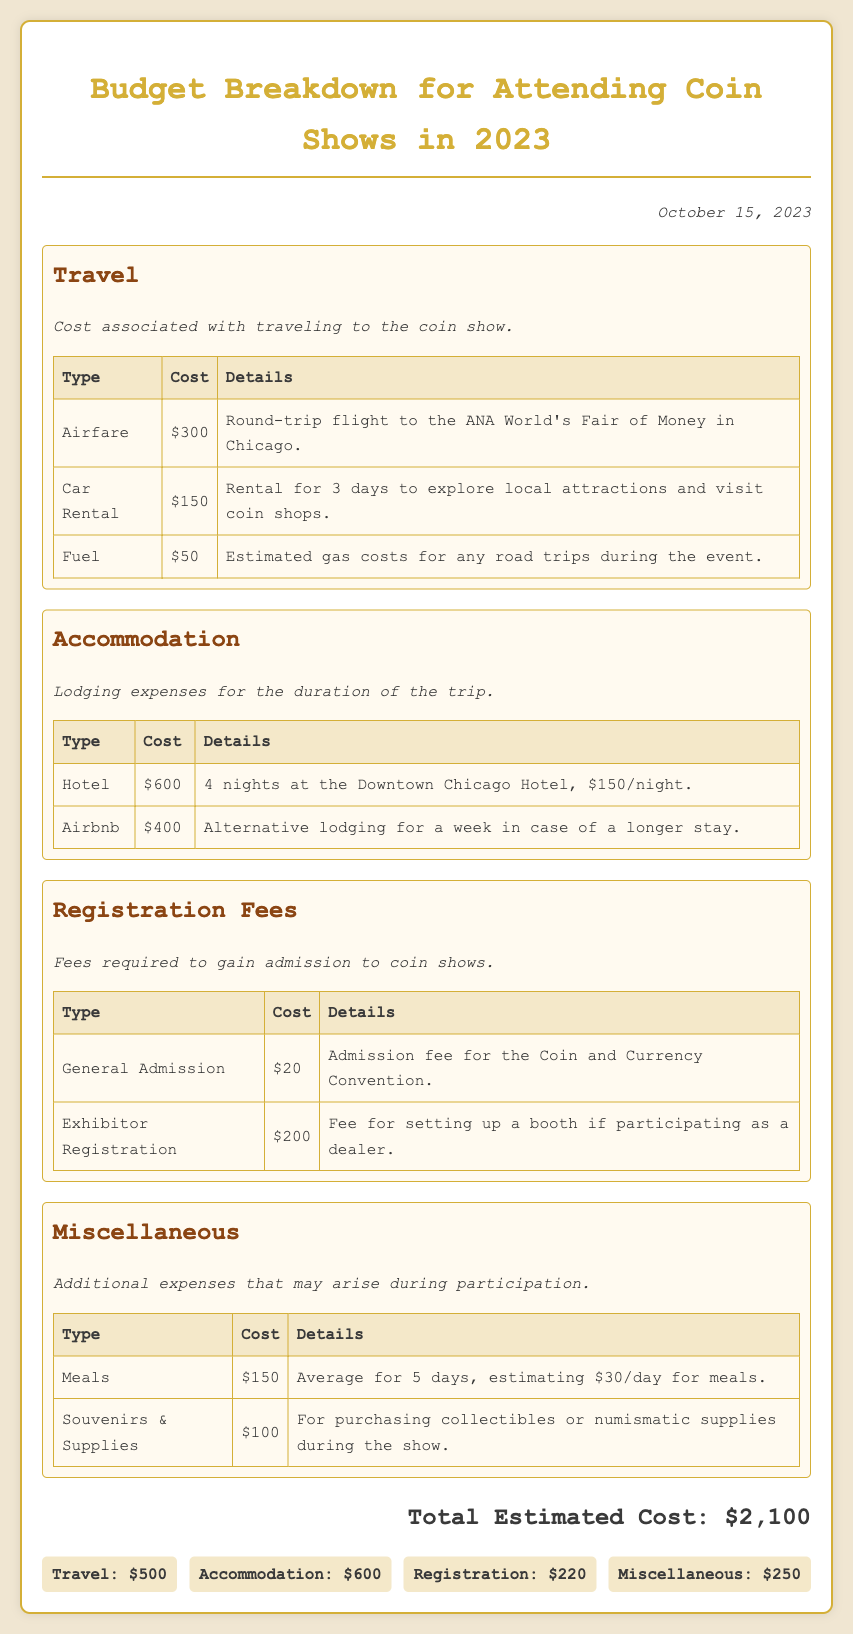What is the total estimated cost for attending the coin shows? The total estimated cost is displayed prominently in the document as $2,100.
Answer: $2,100 How much does airfare cost? The document lists airfare as a cost of $300 for the round-trip flight.
Answer: $300 What type of lodging option is $600? The document mentions that $600 is for the hotel accommodation over 4 nights at the Downtown Chicago Hotel.
Answer: Hotel What is the cost of the exhibitor registration fee? The exhibitor registration fee is provided in the document as $200.
Answer: $200 How much is allocated for meals? The budget allocates $150 for meals over the duration of the trip.
Answer: $150 What is the total cost of travel expenses? Total travel expenses can be calculated by adding airfare, car rental, and fuel costs, resulting in $500.
Answer: $500 What is the registration fee for general admission? The document states that the registration fee for general admission is $20.
Answer: $20 What is one miscellaneous expense mentioned in the budget? The budget lists "Souvenirs & Supplies" as one of the miscellaneous expenses.
Answer: Souvenirs & Supplies How many nights does the hotel cost cover? The hotel cost mentioned covers a total of 4 nights.
Answer: 4 nights 